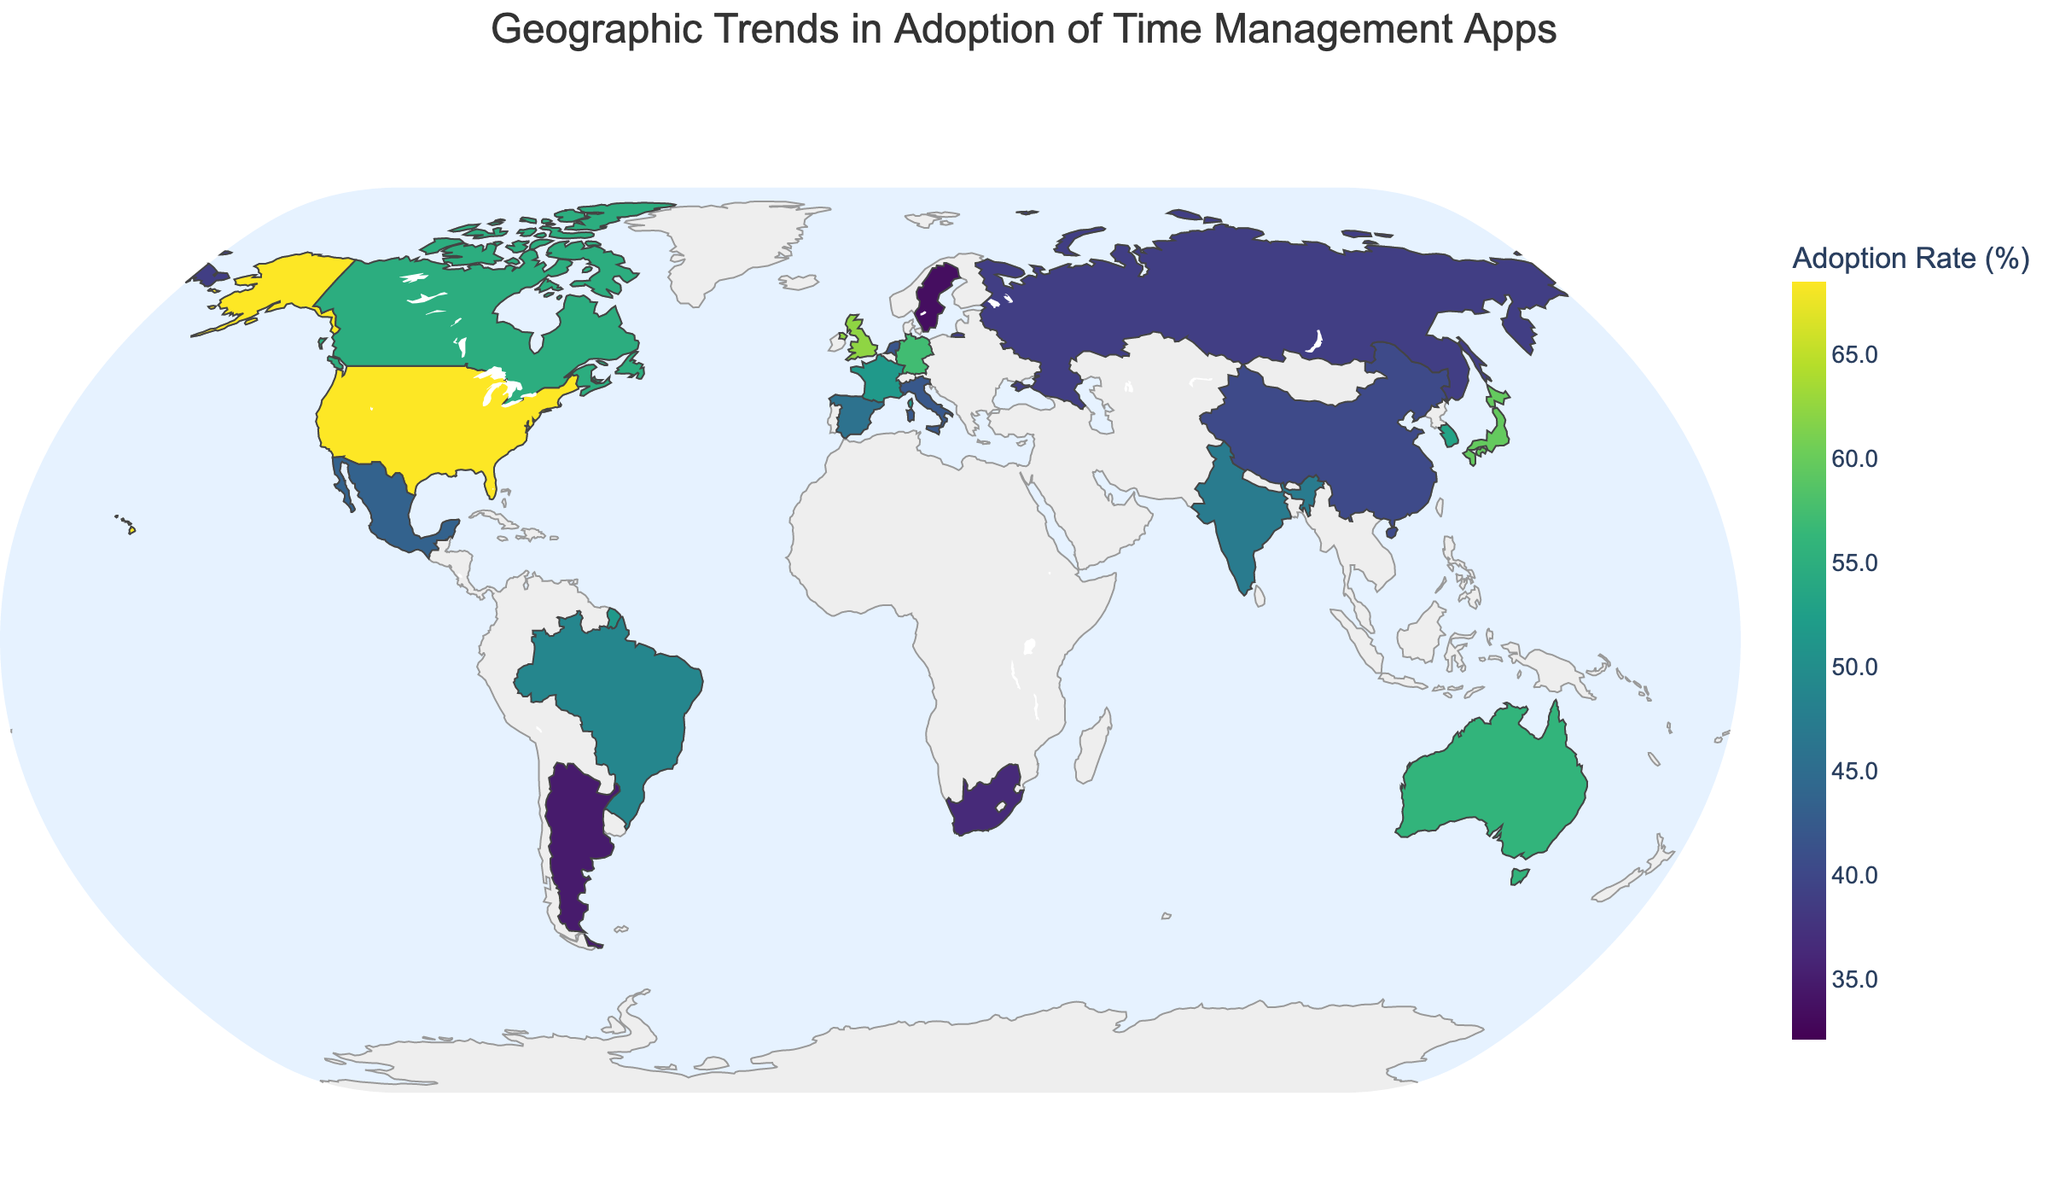How many regions are represented on the map? By examining the figure, we can see the hover data displays the different regions where the countries are located. Counting the unique regions gives us the answer.
Answer: 6 Which country has the highest adoption rate? We look for the country with the darkest color, corresponding to the highest value in the color scale. The hover data will confirm that the United States has the highest adoption rate at 68.5%.
Answer: United States Compare the adoption rates of North American countries. Which has the lowest rate? The North American countries shown are the United States, Canada, and Mexico. By comparing the hover data, Mexico has the lowest rate at 43.5%.
Answer: Mexico What is the average adoption rate of the European countries? The European countries are the United Kingdom, Germany, France, Spain, Italy, Netherlands, Russia, and Sweden. Their adoption rates are 62.3, 57.2, 51.6, 45.8, 42.1, 41.7, 38.9, and 33.5. Summing these gives 373.1, and dividing by 8 gives 46.6375.
Answer: 46.6 Which regions have countries with an adoption rate above 50%? European, North American, and Asian regions all have countries with adoption rates above 50%, as could be seen from the color intensities and confirmed via hover data.
Answer: Europe, North America, Asia What is the range of adoption rates in Asia? The Asian countries are Japan, South Korea, India, China, and Singapore. Their rates are 59.7, 53.1, 47.2, 40.3, and 32.1, respectively. The range is found by subtracting the smallest rate from the largest, 59.7 - 32.1 = 27.6.
Answer: 27.6 Which continent has both the highest and the lowest adoption rates? Examining the hover data for the continents, Asia has both the highest rate in Japan (59.7%) and the lowest rate in Singapore (32.1%).
Answer: Asia How many countries have an adoption rate below 40%? Countries with adoption rates below 40% are Russia (38.9%), South Africa (36.4%), Argentina (34.8%), Sweden (33.5%), and Singapore (32.1%). Counting these gives 5 countries.
Answer: 5 Is there a noticeable geographic trend in adoption rates between North and South America? North American countries (USA, Canada, Mexico) have higher adoption rates (68.5%, 54.8%, 43.5%) compared to South American countries (Brazil, Argentina) with lower adoption rates (48.9%, 34.8%).
Answer: Yes 